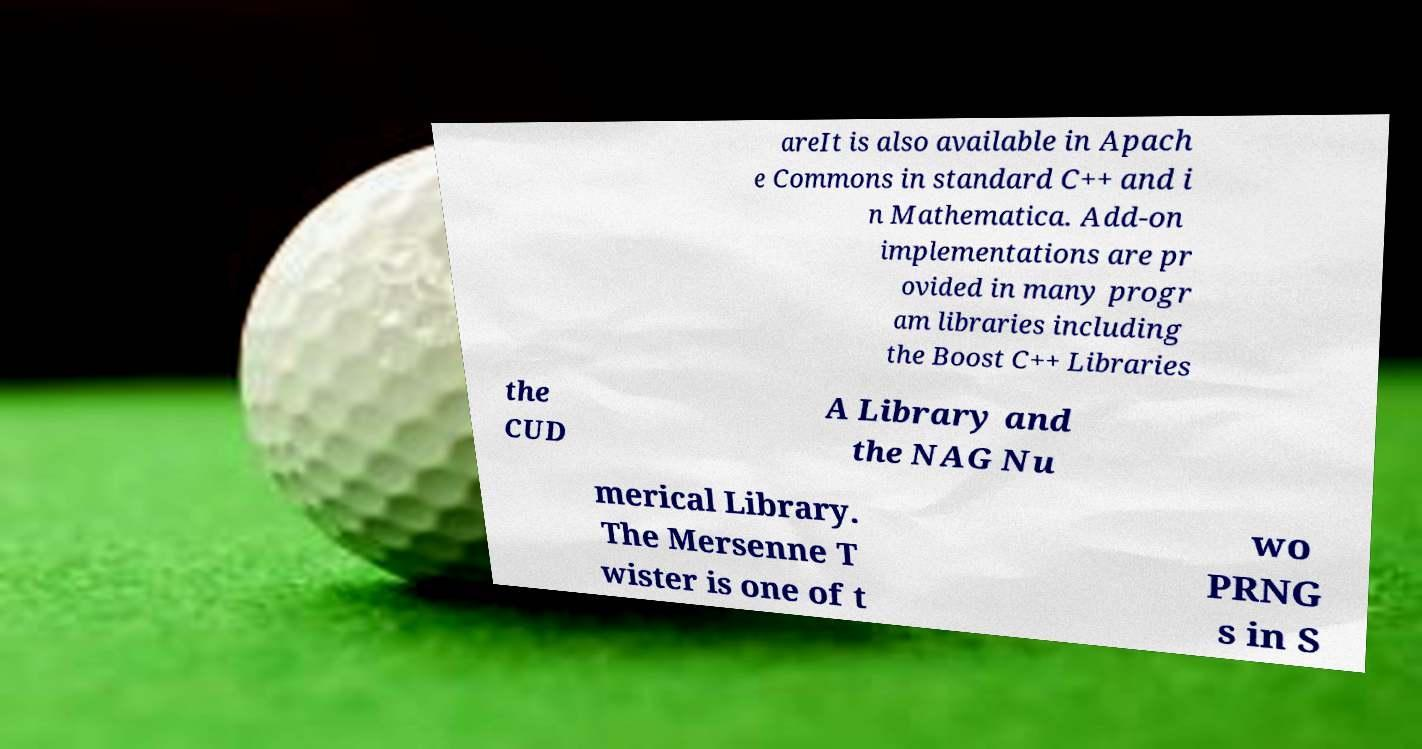Could you assist in decoding the text presented in this image and type it out clearly? areIt is also available in Apach e Commons in standard C++ and i n Mathematica. Add-on implementations are pr ovided in many progr am libraries including the Boost C++ Libraries the CUD A Library and the NAG Nu merical Library. The Mersenne T wister is one of t wo PRNG s in S 